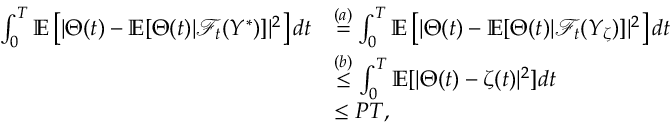Convert formula to latex. <formula><loc_0><loc_0><loc_500><loc_500>\begin{array} { r l } { \int _ { 0 } ^ { T } \mathbb { E } \left [ | \Theta ( t ) - \mathbb { E } [ \Theta ( t ) | \mathcal { F } _ { t } ( Y ^ { \ast } ) ] | ^ { 2 } \right ] d t } & { \overset { ( a ) } { = } \int _ { 0 } ^ { T } \mathbb { E } \left [ | \Theta ( t ) - \mathbb { E } [ \Theta ( t ) | \mathcal { F } _ { t } ( Y _ { \zeta } ) ] | ^ { 2 } \right ] d t } \\ & { \overset { ( b ) } { \leq } \int _ { 0 } ^ { T } \mathbb { E } [ | \Theta ( t ) - \zeta ( t ) | ^ { 2 } ] d t } \\ & { \leq P T , } \end{array}</formula> 